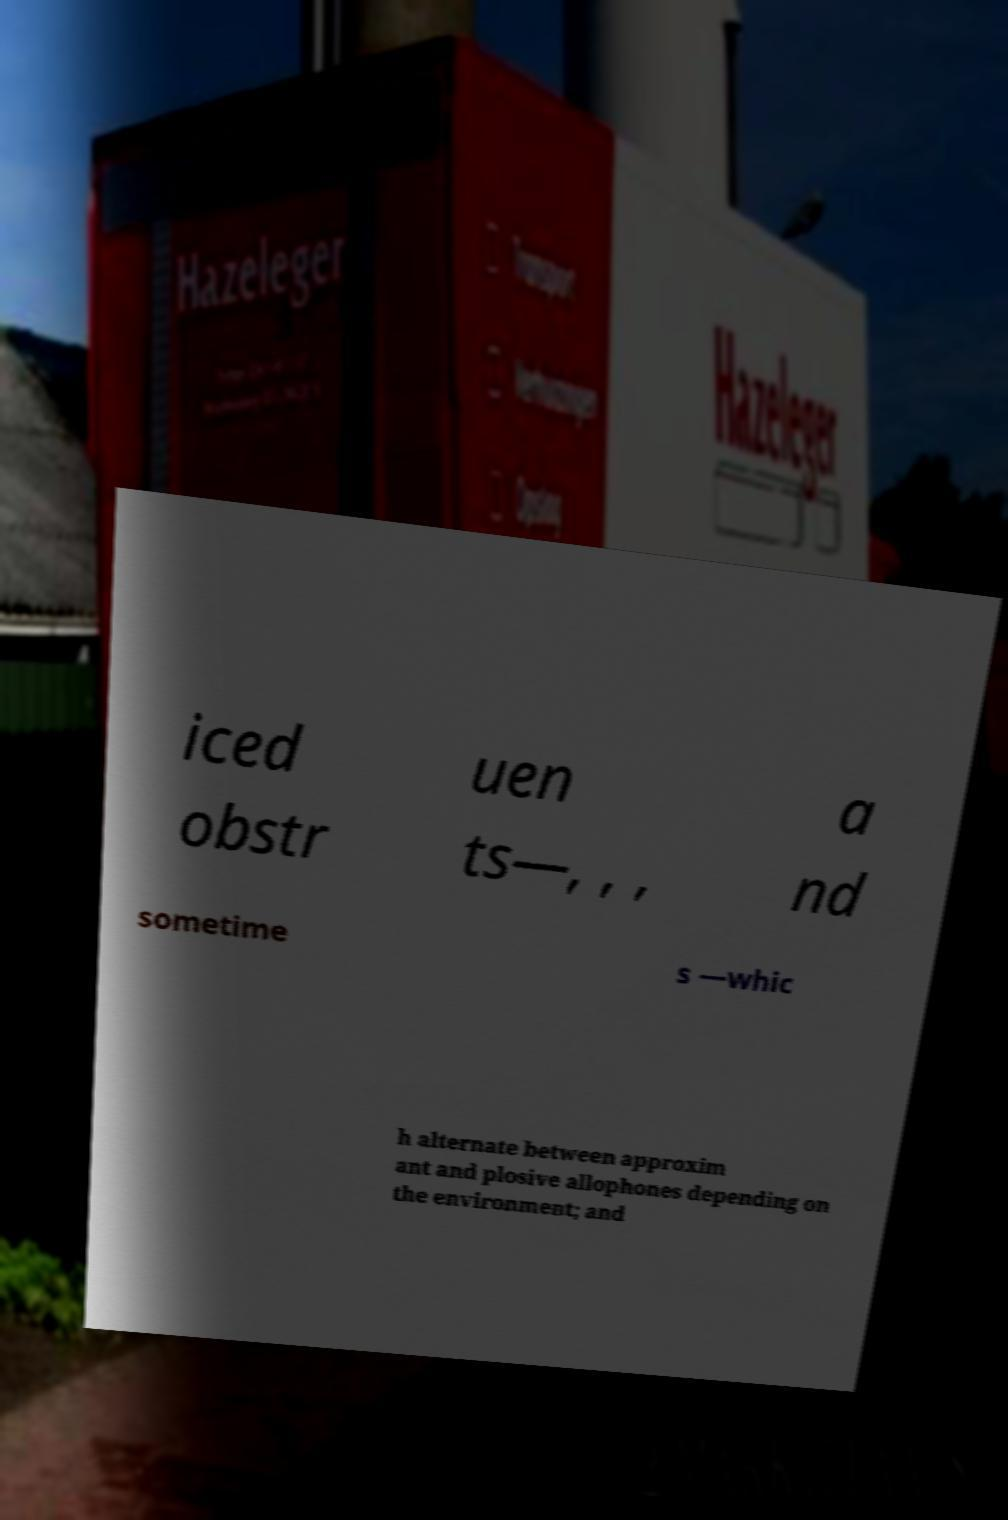For documentation purposes, I need the text within this image transcribed. Could you provide that? iced obstr uen ts—, , , a nd sometime s —whic h alternate between approxim ant and plosive allophones depending on the environment; and 